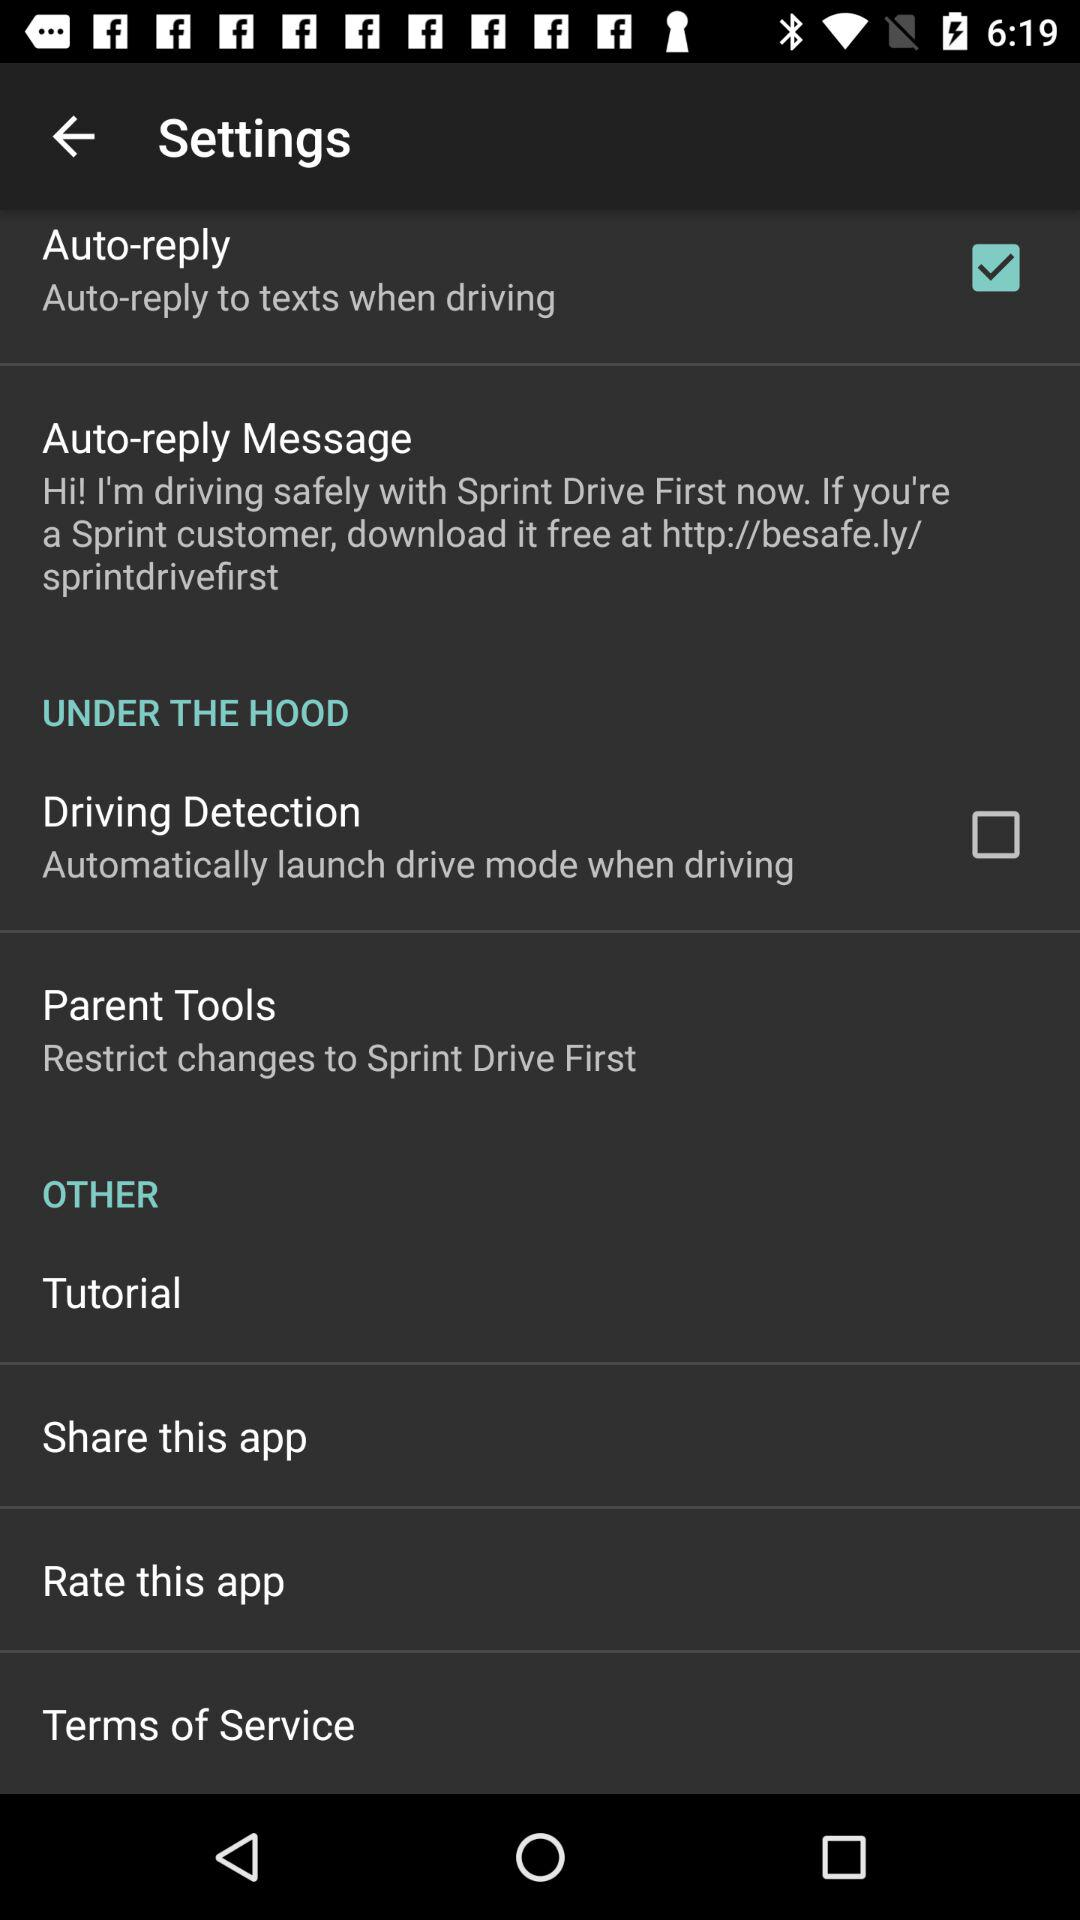How long is the tutorial?
When the provided information is insufficient, respond with <no answer>. <no answer> 